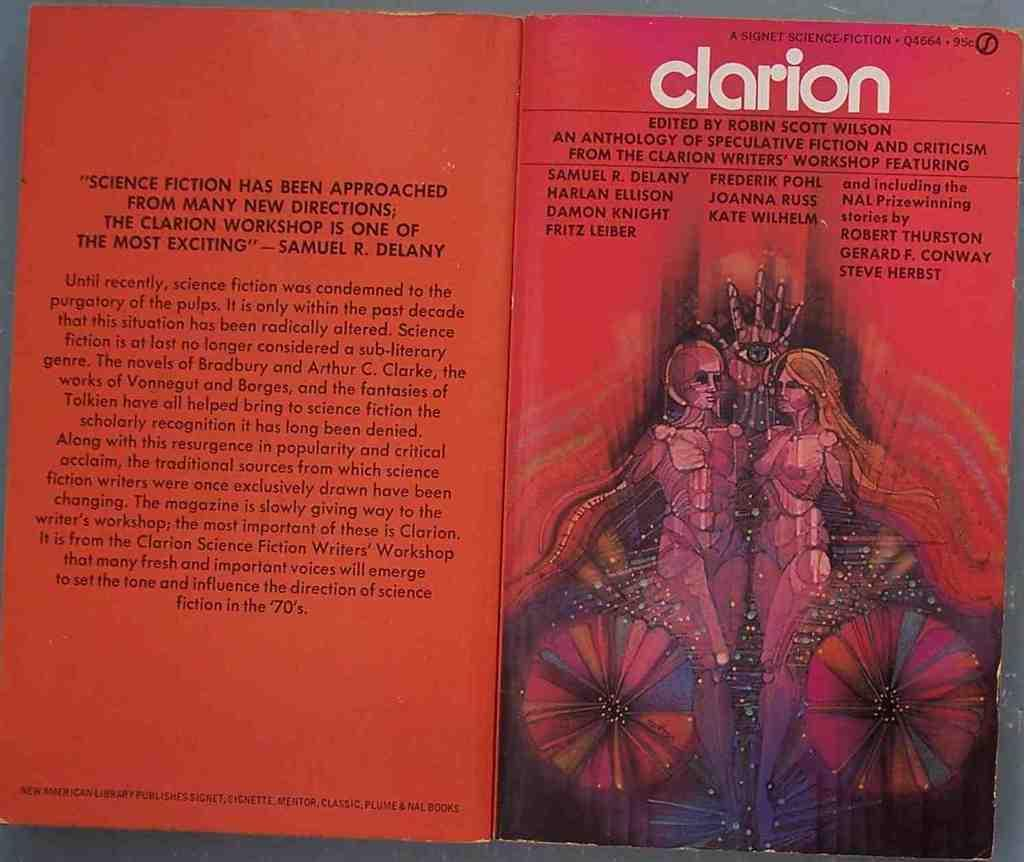<image>
Render a clear and concise summary of the photo. a science fiction book called the clarion is red with a picture on teh front of women 